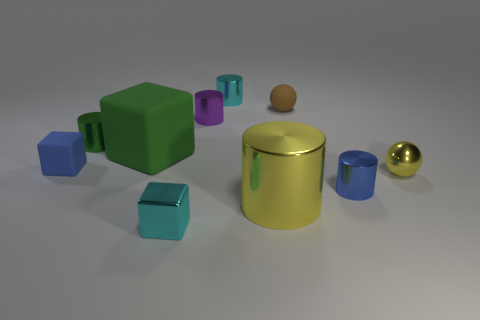What size is the thing that is behind the purple thing and on the left side of the brown thing?
Provide a succinct answer. Small. The tiny metallic thing that is behind the tiny blue rubber thing and left of the purple metallic thing is what color?
Provide a short and direct response. Green. Is the number of tiny blue metal objects that are in front of the small cyan block less than the number of tiny blue shiny objects that are on the left side of the yellow sphere?
Provide a succinct answer. Yes. Is there any other thing that is the same color as the large rubber thing?
Ensure brevity in your answer.  Yes. The big shiny thing has what shape?
Provide a short and direct response. Cylinder. There is a small ball that is made of the same material as the small purple thing; what is its color?
Your response must be concise. Yellow. Is the number of tiny blue cylinders greater than the number of metal cylinders?
Give a very brief answer. No. Are there any blocks?
Your response must be concise. Yes. There is a metal object that is to the right of the tiny cylinder that is in front of the large block; what is its shape?
Offer a terse response. Sphere. How many objects are matte blocks or cylinders that are in front of the tiny blue rubber block?
Provide a short and direct response. 4. 